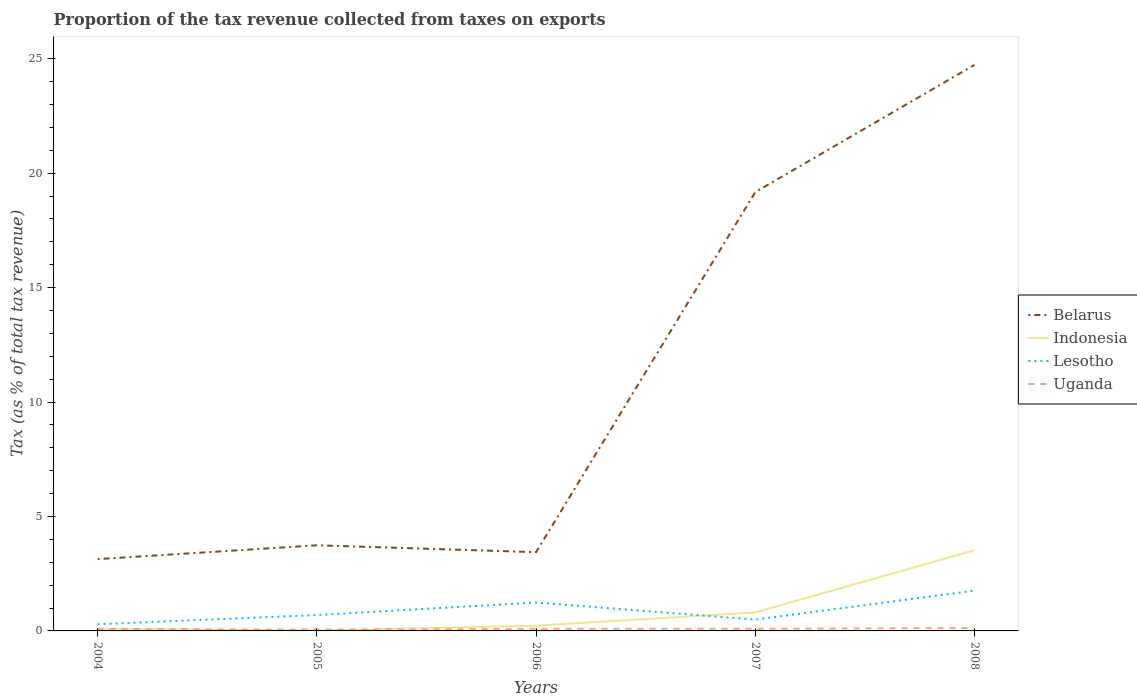Does the line corresponding to Belarus intersect with the line corresponding to Uganda?
Give a very brief answer. No. Across all years, what is the maximum proportion of the tax revenue collected in Indonesia?
Offer a terse response. 0.02. In which year was the proportion of the tax revenue collected in Indonesia maximum?
Give a very brief answer. 2005. What is the total proportion of the tax revenue collected in Indonesia in the graph?
Offer a terse response. -3.3. What is the difference between the highest and the second highest proportion of the tax revenue collected in Indonesia?
Your answer should be compact. 3.51. What is the difference between the highest and the lowest proportion of the tax revenue collected in Uganda?
Offer a very short reply. 2. Is the proportion of the tax revenue collected in Uganda strictly greater than the proportion of the tax revenue collected in Indonesia over the years?
Your answer should be very brief. No. How many lines are there?
Provide a succinct answer. 4. Are the values on the major ticks of Y-axis written in scientific E-notation?
Offer a very short reply. No. Does the graph contain grids?
Provide a short and direct response. No. Where does the legend appear in the graph?
Offer a very short reply. Center right. How many legend labels are there?
Make the answer very short. 4. How are the legend labels stacked?
Your answer should be very brief. Vertical. What is the title of the graph?
Give a very brief answer. Proportion of the tax revenue collected from taxes on exports. What is the label or title of the X-axis?
Keep it short and to the point. Years. What is the label or title of the Y-axis?
Make the answer very short. Tax (as % of total tax revenue). What is the Tax (as % of total tax revenue) of Belarus in 2004?
Ensure brevity in your answer.  3.14. What is the Tax (as % of total tax revenue) of Indonesia in 2004?
Offer a terse response. 0.11. What is the Tax (as % of total tax revenue) of Lesotho in 2004?
Keep it short and to the point. 0.29. What is the Tax (as % of total tax revenue) in Uganda in 2004?
Ensure brevity in your answer.  0.08. What is the Tax (as % of total tax revenue) of Belarus in 2005?
Ensure brevity in your answer.  3.74. What is the Tax (as % of total tax revenue) of Indonesia in 2005?
Your answer should be compact. 0.02. What is the Tax (as % of total tax revenue) in Lesotho in 2005?
Provide a succinct answer. 0.7. What is the Tax (as % of total tax revenue) in Uganda in 2005?
Offer a terse response. 0.06. What is the Tax (as % of total tax revenue) of Belarus in 2006?
Your response must be concise. 3.44. What is the Tax (as % of total tax revenue) of Indonesia in 2006?
Your answer should be very brief. 0.23. What is the Tax (as % of total tax revenue) in Lesotho in 2006?
Offer a terse response. 1.24. What is the Tax (as % of total tax revenue) in Uganda in 2006?
Your answer should be very brief. 0.09. What is the Tax (as % of total tax revenue) of Belarus in 2007?
Offer a very short reply. 19.17. What is the Tax (as % of total tax revenue) of Indonesia in 2007?
Offer a terse response. 0.81. What is the Tax (as % of total tax revenue) of Lesotho in 2007?
Your answer should be compact. 0.49. What is the Tax (as % of total tax revenue) of Uganda in 2007?
Provide a succinct answer. 0.09. What is the Tax (as % of total tax revenue) in Belarus in 2008?
Provide a short and direct response. 24.73. What is the Tax (as % of total tax revenue) in Indonesia in 2008?
Provide a short and direct response. 3.53. What is the Tax (as % of total tax revenue) in Lesotho in 2008?
Provide a succinct answer. 1.76. What is the Tax (as % of total tax revenue) of Uganda in 2008?
Provide a succinct answer. 0.13. Across all years, what is the maximum Tax (as % of total tax revenue) of Belarus?
Your answer should be very brief. 24.73. Across all years, what is the maximum Tax (as % of total tax revenue) in Indonesia?
Your response must be concise. 3.53. Across all years, what is the maximum Tax (as % of total tax revenue) in Lesotho?
Ensure brevity in your answer.  1.76. Across all years, what is the maximum Tax (as % of total tax revenue) of Uganda?
Make the answer very short. 0.13. Across all years, what is the minimum Tax (as % of total tax revenue) of Belarus?
Offer a terse response. 3.14. Across all years, what is the minimum Tax (as % of total tax revenue) in Indonesia?
Provide a short and direct response. 0.02. Across all years, what is the minimum Tax (as % of total tax revenue) in Lesotho?
Offer a terse response. 0.29. Across all years, what is the minimum Tax (as % of total tax revenue) of Uganda?
Your response must be concise. 0.06. What is the total Tax (as % of total tax revenue) of Belarus in the graph?
Offer a terse response. 54.23. What is the total Tax (as % of total tax revenue) of Indonesia in the graph?
Offer a terse response. 4.69. What is the total Tax (as % of total tax revenue) of Lesotho in the graph?
Your answer should be very brief. 4.48. What is the total Tax (as % of total tax revenue) of Uganda in the graph?
Provide a succinct answer. 0.46. What is the difference between the Tax (as % of total tax revenue) in Belarus in 2004 and that in 2005?
Provide a short and direct response. -0.6. What is the difference between the Tax (as % of total tax revenue) of Indonesia in 2004 and that in 2005?
Your answer should be compact. 0.09. What is the difference between the Tax (as % of total tax revenue) of Lesotho in 2004 and that in 2005?
Your answer should be very brief. -0.4. What is the difference between the Tax (as % of total tax revenue) in Uganda in 2004 and that in 2005?
Provide a succinct answer. 0.02. What is the difference between the Tax (as % of total tax revenue) in Belarus in 2004 and that in 2006?
Provide a short and direct response. -0.3. What is the difference between the Tax (as % of total tax revenue) of Indonesia in 2004 and that in 2006?
Keep it short and to the point. -0.12. What is the difference between the Tax (as % of total tax revenue) of Lesotho in 2004 and that in 2006?
Provide a short and direct response. -0.95. What is the difference between the Tax (as % of total tax revenue) of Uganda in 2004 and that in 2006?
Your answer should be compact. -0.01. What is the difference between the Tax (as % of total tax revenue) in Belarus in 2004 and that in 2007?
Your response must be concise. -16.04. What is the difference between the Tax (as % of total tax revenue) of Indonesia in 2004 and that in 2007?
Provide a short and direct response. -0.7. What is the difference between the Tax (as % of total tax revenue) in Lesotho in 2004 and that in 2007?
Keep it short and to the point. -0.2. What is the difference between the Tax (as % of total tax revenue) in Uganda in 2004 and that in 2007?
Ensure brevity in your answer.  -0.01. What is the difference between the Tax (as % of total tax revenue) of Belarus in 2004 and that in 2008?
Your answer should be very brief. -21.6. What is the difference between the Tax (as % of total tax revenue) in Indonesia in 2004 and that in 2008?
Offer a terse response. -3.42. What is the difference between the Tax (as % of total tax revenue) of Lesotho in 2004 and that in 2008?
Offer a very short reply. -1.47. What is the difference between the Tax (as % of total tax revenue) in Uganda in 2004 and that in 2008?
Provide a short and direct response. -0.04. What is the difference between the Tax (as % of total tax revenue) of Belarus in 2005 and that in 2006?
Your answer should be compact. 0.3. What is the difference between the Tax (as % of total tax revenue) in Indonesia in 2005 and that in 2006?
Your answer should be very brief. -0.21. What is the difference between the Tax (as % of total tax revenue) of Lesotho in 2005 and that in 2006?
Your response must be concise. -0.55. What is the difference between the Tax (as % of total tax revenue) of Uganda in 2005 and that in 2006?
Offer a terse response. -0.03. What is the difference between the Tax (as % of total tax revenue) in Belarus in 2005 and that in 2007?
Provide a short and direct response. -15.43. What is the difference between the Tax (as % of total tax revenue) of Indonesia in 2005 and that in 2007?
Give a very brief answer. -0.79. What is the difference between the Tax (as % of total tax revenue) in Lesotho in 2005 and that in 2007?
Make the answer very short. 0.2. What is the difference between the Tax (as % of total tax revenue) in Uganda in 2005 and that in 2007?
Your answer should be very brief. -0.03. What is the difference between the Tax (as % of total tax revenue) in Belarus in 2005 and that in 2008?
Give a very brief answer. -20.99. What is the difference between the Tax (as % of total tax revenue) of Indonesia in 2005 and that in 2008?
Your answer should be very brief. -3.51. What is the difference between the Tax (as % of total tax revenue) of Lesotho in 2005 and that in 2008?
Keep it short and to the point. -1.07. What is the difference between the Tax (as % of total tax revenue) of Uganda in 2005 and that in 2008?
Provide a succinct answer. -0.07. What is the difference between the Tax (as % of total tax revenue) of Belarus in 2006 and that in 2007?
Provide a short and direct response. -15.73. What is the difference between the Tax (as % of total tax revenue) of Indonesia in 2006 and that in 2007?
Your answer should be very brief. -0.58. What is the difference between the Tax (as % of total tax revenue) of Lesotho in 2006 and that in 2007?
Provide a succinct answer. 0.75. What is the difference between the Tax (as % of total tax revenue) in Uganda in 2006 and that in 2007?
Provide a succinct answer. -0. What is the difference between the Tax (as % of total tax revenue) in Belarus in 2006 and that in 2008?
Your answer should be very brief. -21.29. What is the difference between the Tax (as % of total tax revenue) in Indonesia in 2006 and that in 2008?
Make the answer very short. -3.3. What is the difference between the Tax (as % of total tax revenue) of Lesotho in 2006 and that in 2008?
Provide a succinct answer. -0.52. What is the difference between the Tax (as % of total tax revenue) of Uganda in 2006 and that in 2008?
Provide a short and direct response. -0.04. What is the difference between the Tax (as % of total tax revenue) of Belarus in 2007 and that in 2008?
Your response must be concise. -5.56. What is the difference between the Tax (as % of total tax revenue) in Indonesia in 2007 and that in 2008?
Make the answer very short. -2.72. What is the difference between the Tax (as % of total tax revenue) in Lesotho in 2007 and that in 2008?
Provide a short and direct response. -1.27. What is the difference between the Tax (as % of total tax revenue) of Uganda in 2007 and that in 2008?
Your answer should be very brief. -0.04. What is the difference between the Tax (as % of total tax revenue) in Belarus in 2004 and the Tax (as % of total tax revenue) in Indonesia in 2005?
Your response must be concise. 3.12. What is the difference between the Tax (as % of total tax revenue) of Belarus in 2004 and the Tax (as % of total tax revenue) of Lesotho in 2005?
Provide a short and direct response. 2.44. What is the difference between the Tax (as % of total tax revenue) in Belarus in 2004 and the Tax (as % of total tax revenue) in Uganda in 2005?
Your answer should be very brief. 3.08. What is the difference between the Tax (as % of total tax revenue) of Indonesia in 2004 and the Tax (as % of total tax revenue) of Lesotho in 2005?
Provide a short and direct response. -0.59. What is the difference between the Tax (as % of total tax revenue) of Indonesia in 2004 and the Tax (as % of total tax revenue) of Uganda in 2005?
Make the answer very short. 0.04. What is the difference between the Tax (as % of total tax revenue) of Lesotho in 2004 and the Tax (as % of total tax revenue) of Uganda in 2005?
Provide a succinct answer. 0.23. What is the difference between the Tax (as % of total tax revenue) of Belarus in 2004 and the Tax (as % of total tax revenue) of Indonesia in 2006?
Keep it short and to the point. 2.91. What is the difference between the Tax (as % of total tax revenue) of Belarus in 2004 and the Tax (as % of total tax revenue) of Lesotho in 2006?
Offer a terse response. 1.9. What is the difference between the Tax (as % of total tax revenue) in Belarus in 2004 and the Tax (as % of total tax revenue) in Uganda in 2006?
Give a very brief answer. 3.05. What is the difference between the Tax (as % of total tax revenue) in Indonesia in 2004 and the Tax (as % of total tax revenue) in Lesotho in 2006?
Your answer should be compact. -1.14. What is the difference between the Tax (as % of total tax revenue) in Indonesia in 2004 and the Tax (as % of total tax revenue) in Uganda in 2006?
Provide a short and direct response. 0.01. What is the difference between the Tax (as % of total tax revenue) in Lesotho in 2004 and the Tax (as % of total tax revenue) in Uganda in 2006?
Your answer should be compact. 0.2. What is the difference between the Tax (as % of total tax revenue) of Belarus in 2004 and the Tax (as % of total tax revenue) of Indonesia in 2007?
Offer a terse response. 2.33. What is the difference between the Tax (as % of total tax revenue) in Belarus in 2004 and the Tax (as % of total tax revenue) in Lesotho in 2007?
Keep it short and to the point. 2.64. What is the difference between the Tax (as % of total tax revenue) of Belarus in 2004 and the Tax (as % of total tax revenue) of Uganda in 2007?
Provide a short and direct response. 3.04. What is the difference between the Tax (as % of total tax revenue) in Indonesia in 2004 and the Tax (as % of total tax revenue) in Lesotho in 2007?
Provide a succinct answer. -0.39. What is the difference between the Tax (as % of total tax revenue) in Indonesia in 2004 and the Tax (as % of total tax revenue) in Uganda in 2007?
Keep it short and to the point. 0.01. What is the difference between the Tax (as % of total tax revenue) in Lesotho in 2004 and the Tax (as % of total tax revenue) in Uganda in 2007?
Keep it short and to the point. 0.2. What is the difference between the Tax (as % of total tax revenue) of Belarus in 2004 and the Tax (as % of total tax revenue) of Indonesia in 2008?
Make the answer very short. -0.39. What is the difference between the Tax (as % of total tax revenue) of Belarus in 2004 and the Tax (as % of total tax revenue) of Lesotho in 2008?
Provide a short and direct response. 1.38. What is the difference between the Tax (as % of total tax revenue) of Belarus in 2004 and the Tax (as % of total tax revenue) of Uganda in 2008?
Your answer should be compact. 3.01. What is the difference between the Tax (as % of total tax revenue) of Indonesia in 2004 and the Tax (as % of total tax revenue) of Lesotho in 2008?
Offer a very short reply. -1.66. What is the difference between the Tax (as % of total tax revenue) of Indonesia in 2004 and the Tax (as % of total tax revenue) of Uganda in 2008?
Your answer should be very brief. -0.02. What is the difference between the Tax (as % of total tax revenue) in Lesotho in 2004 and the Tax (as % of total tax revenue) in Uganda in 2008?
Offer a very short reply. 0.16. What is the difference between the Tax (as % of total tax revenue) of Belarus in 2005 and the Tax (as % of total tax revenue) of Indonesia in 2006?
Keep it short and to the point. 3.51. What is the difference between the Tax (as % of total tax revenue) of Belarus in 2005 and the Tax (as % of total tax revenue) of Lesotho in 2006?
Give a very brief answer. 2.5. What is the difference between the Tax (as % of total tax revenue) in Belarus in 2005 and the Tax (as % of total tax revenue) in Uganda in 2006?
Keep it short and to the point. 3.65. What is the difference between the Tax (as % of total tax revenue) in Indonesia in 2005 and the Tax (as % of total tax revenue) in Lesotho in 2006?
Your response must be concise. -1.22. What is the difference between the Tax (as % of total tax revenue) in Indonesia in 2005 and the Tax (as % of total tax revenue) in Uganda in 2006?
Make the answer very short. -0.07. What is the difference between the Tax (as % of total tax revenue) of Lesotho in 2005 and the Tax (as % of total tax revenue) of Uganda in 2006?
Your response must be concise. 0.6. What is the difference between the Tax (as % of total tax revenue) of Belarus in 2005 and the Tax (as % of total tax revenue) of Indonesia in 2007?
Your answer should be compact. 2.93. What is the difference between the Tax (as % of total tax revenue) of Belarus in 2005 and the Tax (as % of total tax revenue) of Lesotho in 2007?
Offer a very short reply. 3.25. What is the difference between the Tax (as % of total tax revenue) in Belarus in 2005 and the Tax (as % of total tax revenue) in Uganda in 2007?
Your answer should be very brief. 3.65. What is the difference between the Tax (as % of total tax revenue) in Indonesia in 2005 and the Tax (as % of total tax revenue) in Lesotho in 2007?
Offer a very short reply. -0.48. What is the difference between the Tax (as % of total tax revenue) in Indonesia in 2005 and the Tax (as % of total tax revenue) in Uganda in 2007?
Keep it short and to the point. -0.08. What is the difference between the Tax (as % of total tax revenue) of Lesotho in 2005 and the Tax (as % of total tax revenue) of Uganda in 2007?
Your answer should be very brief. 0.6. What is the difference between the Tax (as % of total tax revenue) in Belarus in 2005 and the Tax (as % of total tax revenue) in Indonesia in 2008?
Your answer should be compact. 0.21. What is the difference between the Tax (as % of total tax revenue) of Belarus in 2005 and the Tax (as % of total tax revenue) of Lesotho in 2008?
Your answer should be very brief. 1.98. What is the difference between the Tax (as % of total tax revenue) of Belarus in 2005 and the Tax (as % of total tax revenue) of Uganda in 2008?
Your response must be concise. 3.61. What is the difference between the Tax (as % of total tax revenue) in Indonesia in 2005 and the Tax (as % of total tax revenue) in Lesotho in 2008?
Keep it short and to the point. -1.74. What is the difference between the Tax (as % of total tax revenue) of Indonesia in 2005 and the Tax (as % of total tax revenue) of Uganda in 2008?
Your answer should be very brief. -0.11. What is the difference between the Tax (as % of total tax revenue) of Lesotho in 2005 and the Tax (as % of total tax revenue) of Uganda in 2008?
Your answer should be compact. 0.57. What is the difference between the Tax (as % of total tax revenue) of Belarus in 2006 and the Tax (as % of total tax revenue) of Indonesia in 2007?
Offer a terse response. 2.63. What is the difference between the Tax (as % of total tax revenue) of Belarus in 2006 and the Tax (as % of total tax revenue) of Lesotho in 2007?
Offer a very short reply. 2.95. What is the difference between the Tax (as % of total tax revenue) in Belarus in 2006 and the Tax (as % of total tax revenue) in Uganda in 2007?
Your answer should be very brief. 3.35. What is the difference between the Tax (as % of total tax revenue) of Indonesia in 2006 and the Tax (as % of total tax revenue) of Lesotho in 2007?
Your answer should be compact. -0.27. What is the difference between the Tax (as % of total tax revenue) of Indonesia in 2006 and the Tax (as % of total tax revenue) of Uganda in 2007?
Your response must be concise. 0.14. What is the difference between the Tax (as % of total tax revenue) in Lesotho in 2006 and the Tax (as % of total tax revenue) in Uganda in 2007?
Give a very brief answer. 1.15. What is the difference between the Tax (as % of total tax revenue) in Belarus in 2006 and the Tax (as % of total tax revenue) in Indonesia in 2008?
Make the answer very short. -0.09. What is the difference between the Tax (as % of total tax revenue) of Belarus in 2006 and the Tax (as % of total tax revenue) of Lesotho in 2008?
Provide a short and direct response. 1.68. What is the difference between the Tax (as % of total tax revenue) in Belarus in 2006 and the Tax (as % of total tax revenue) in Uganda in 2008?
Provide a short and direct response. 3.31. What is the difference between the Tax (as % of total tax revenue) of Indonesia in 2006 and the Tax (as % of total tax revenue) of Lesotho in 2008?
Give a very brief answer. -1.53. What is the difference between the Tax (as % of total tax revenue) in Indonesia in 2006 and the Tax (as % of total tax revenue) in Uganda in 2008?
Keep it short and to the point. 0.1. What is the difference between the Tax (as % of total tax revenue) in Lesotho in 2006 and the Tax (as % of total tax revenue) in Uganda in 2008?
Your response must be concise. 1.11. What is the difference between the Tax (as % of total tax revenue) in Belarus in 2007 and the Tax (as % of total tax revenue) in Indonesia in 2008?
Your response must be concise. 15.65. What is the difference between the Tax (as % of total tax revenue) of Belarus in 2007 and the Tax (as % of total tax revenue) of Lesotho in 2008?
Make the answer very short. 17.41. What is the difference between the Tax (as % of total tax revenue) of Belarus in 2007 and the Tax (as % of total tax revenue) of Uganda in 2008?
Provide a succinct answer. 19.05. What is the difference between the Tax (as % of total tax revenue) in Indonesia in 2007 and the Tax (as % of total tax revenue) in Lesotho in 2008?
Your response must be concise. -0.95. What is the difference between the Tax (as % of total tax revenue) in Indonesia in 2007 and the Tax (as % of total tax revenue) in Uganda in 2008?
Make the answer very short. 0.68. What is the difference between the Tax (as % of total tax revenue) of Lesotho in 2007 and the Tax (as % of total tax revenue) of Uganda in 2008?
Make the answer very short. 0.37. What is the average Tax (as % of total tax revenue) in Belarus per year?
Offer a terse response. 10.85. What is the average Tax (as % of total tax revenue) in Indonesia per year?
Keep it short and to the point. 0.94. What is the average Tax (as % of total tax revenue) of Lesotho per year?
Provide a short and direct response. 0.9. What is the average Tax (as % of total tax revenue) in Uganda per year?
Provide a short and direct response. 0.09. In the year 2004, what is the difference between the Tax (as % of total tax revenue) of Belarus and Tax (as % of total tax revenue) of Indonesia?
Your response must be concise. 3.03. In the year 2004, what is the difference between the Tax (as % of total tax revenue) of Belarus and Tax (as % of total tax revenue) of Lesotho?
Your answer should be compact. 2.85. In the year 2004, what is the difference between the Tax (as % of total tax revenue) in Belarus and Tax (as % of total tax revenue) in Uganda?
Your answer should be very brief. 3.05. In the year 2004, what is the difference between the Tax (as % of total tax revenue) of Indonesia and Tax (as % of total tax revenue) of Lesotho?
Ensure brevity in your answer.  -0.19. In the year 2004, what is the difference between the Tax (as % of total tax revenue) in Indonesia and Tax (as % of total tax revenue) in Uganda?
Your answer should be compact. 0.02. In the year 2004, what is the difference between the Tax (as % of total tax revenue) in Lesotho and Tax (as % of total tax revenue) in Uganda?
Make the answer very short. 0.21. In the year 2005, what is the difference between the Tax (as % of total tax revenue) in Belarus and Tax (as % of total tax revenue) in Indonesia?
Provide a short and direct response. 3.72. In the year 2005, what is the difference between the Tax (as % of total tax revenue) of Belarus and Tax (as % of total tax revenue) of Lesotho?
Keep it short and to the point. 3.05. In the year 2005, what is the difference between the Tax (as % of total tax revenue) of Belarus and Tax (as % of total tax revenue) of Uganda?
Your answer should be compact. 3.68. In the year 2005, what is the difference between the Tax (as % of total tax revenue) of Indonesia and Tax (as % of total tax revenue) of Lesotho?
Provide a short and direct response. -0.68. In the year 2005, what is the difference between the Tax (as % of total tax revenue) in Indonesia and Tax (as % of total tax revenue) in Uganda?
Provide a succinct answer. -0.04. In the year 2005, what is the difference between the Tax (as % of total tax revenue) in Lesotho and Tax (as % of total tax revenue) in Uganda?
Keep it short and to the point. 0.63. In the year 2006, what is the difference between the Tax (as % of total tax revenue) in Belarus and Tax (as % of total tax revenue) in Indonesia?
Keep it short and to the point. 3.21. In the year 2006, what is the difference between the Tax (as % of total tax revenue) in Belarus and Tax (as % of total tax revenue) in Lesotho?
Provide a succinct answer. 2.2. In the year 2006, what is the difference between the Tax (as % of total tax revenue) of Belarus and Tax (as % of total tax revenue) of Uganda?
Make the answer very short. 3.35. In the year 2006, what is the difference between the Tax (as % of total tax revenue) of Indonesia and Tax (as % of total tax revenue) of Lesotho?
Provide a succinct answer. -1.01. In the year 2006, what is the difference between the Tax (as % of total tax revenue) in Indonesia and Tax (as % of total tax revenue) in Uganda?
Provide a short and direct response. 0.14. In the year 2006, what is the difference between the Tax (as % of total tax revenue) of Lesotho and Tax (as % of total tax revenue) of Uganda?
Your response must be concise. 1.15. In the year 2007, what is the difference between the Tax (as % of total tax revenue) in Belarus and Tax (as % of total tax revenue) in Indonesia?
Provide a short and direct response. 18.37. In the year 2007, what is the difference between the Tax (as % of total tax revenue) in Belarus and Tax (as % of total tax revenue) in Lesotho?
Provide a succinct answer. 18.68. In the year 2007, what is the difference between the Tax (as % of total tax revenue) of Belarus and Tax (as % of total tax revenue) of Uganda?
Offer a very short reply. 19.08. In the year 2007, what is the difference between the Tax (as % of total tax revenue) of Indonesia and Tax (as % of total tax revenue) of Lesotho?
Make the answer very short. 0.31. In the year 2007, what is the difference between the Tax (as % of total tax revenue) in Indonesia and Tax (as % of total tax revenue) in Uganda?
Your response must be concise. 0.71. In the year 2007, what is the difference between the Tax (as % of total tax revenue) in Lesotho and Tax (as % of total tax revenue) in Uganda?
Offer a very short reply. 0.4. In the year 2008, what is the difference between the Tax (as % of total tax revenue) of Belarus and Tax (as % of total tax revenue) of Indonesia?
Provide a short and direct response. 21.21. In the year 2008, what is the difference between the Tax (as % of total tax revenue) in Belarus and Tax (as % of total tax revenue) in Lesotho?
Offer a terse response. 22.97. In the year 2008, what is the difference between the Tax (as % of total tax revenue) of Belarus and Tax (as % of total tax revenue) of Uganda?
Keep it short and to the point. 24.61. In the year 2008, what is the difference between the Tax (as % of total tax revenue) of Indonesia and Tax (as % of total tax revenue) of Lesotho?
Your answer should be very brief. 1.77. In the year 2008, what is the difference between the Tax (as % of total tax revenue) of Indonesia and Tax (as % of total tax revenue) of Uganda?
Give a very brief answer. 3.4. In the year 2008, what is the difference between the Tax (as % of total tax revenue) of Lesotho and Tax (as % of total tax revenue) of Uganda?
Keep it short and to the point. 1.63. What is the ratio of the Tax (as % of total tax revenue) of Belarus in 2004 to that in 2005?
Make the answer very short. 0.84. What is the ratio of the Tax (as % of total tax revenue) in Indonesia in 2004 to that in 2005?
Your response must be concise. 6.08. What is the ratio of the Tax (as % of total tax revenue) in Lesotho in 2004 to that in 2005?
Offer a terse response. 0.42. What is the ratio of the Tax (as % of total tax revenue) of Uganda in 2004 to that in 2005?
Make the answer very short. 1.4. What is the ratio of the Tax (as % of total tax revenue) in Belarus in 2004 to that in 2006?
Provide a succinct answer. 0.91. What is the ratio of the Tax (as % of total tax revenue) in Indonesia in 2004 to that in 2006?
Your answer should be very brief. 0.46. What is the ratio of the Tax (as % of total tax revenue) in Lesotho in 2004 to that in 2006?
Provide a succinct answer. 0.23. What is the ratio of the Tax (as % of total tax revenue) of Uganda in 2004 to that in 2006?
Keep it short and to the point. 0.93. What is the ratio of the Tax (as % of total tax revenue) in Belarus in 2004 to that in 2007?
Offer a terse response. 0.16. What is the ratio of the Tax (as % of total tax revenue) in Indonesia in 2004 to that in 2007?
Offer a terse response. 0.13. What is the ratio of the Tax (as % of total tax revenue) of Lesotho in 2004 to that in 2007?
Provide a succinct answer. 0.59. What is the ratio of the Tax (as % of total tax revenue) of Uganda in 2004 to that in 2007?
Give a very brief answer. 0.91. What is the ratio of the Tax (as % of total tax revenue) in Belarus in 2004 to that in 2008?
Offer a very short reply. 0.13. What is the ratio of the Tax (as % of total tax revenue) in Indonesia in 2004 to that in 2008?
Offer a terse response. 0.03. What is the ratio of the Tax (as % of total tax revenue) in Lesotho in 2004 to that in 2008?
Ensure brevity in your answer.  0.17. What is the ratio of the Tax (as % of total tax revenue) of Uganda in 2004 to that in 2008?
Give a very brief answer. 0.66. What is the ratio of the Tax (as % of total tax revenue) of Belarus in 2005 to that in 2006?
Your response must be concise. 1.09. What is the ratio of the Tax (as % of total tax revenue) of Indonesia in 2005 to that in 2006?
Make the answer very short. 0.08. What is the ratio of the Tax (as % of total tax revenue) in Lesotho in 2005 to that in 2006?
Provide a succinct answer. 0.56. What is the ratio of the Tax (as % of total tax revenue) in Uganda in 2005 to that in 2006?
Offer a terse response. 0.66. What is the ratio of the Tax (as % of total tax revenue) of Belarus in 2005 to that in 2007?
Make the answer very short. 0.2. What is the ratio of the Tax (as % of total tax revenue) in Indonesia in 2005 to that in 2007?
Offer a very short reply. 0.02. What is the ratio of the Tax (as % of total tax revenue) of Lesotho in 2005 to that in 2007?
Provide a succinct answer. 1.4. What is the ratio of the Tax (as % of total tax revenue) of Uganda in 2005 to that in 2007?
Your answer should be compact. 0.65. What is the ratio of the Tax (as % of total tax revenue) in Belarus in 2005 to that in 2008?
Your answer should be compact. 0.15. What is the ratio of the Tax (as % of total tax revenue) in Indonesia in 2005 to that in 2008?
Give a very brief answer. 0. What is the ratio of the Tax (as % of total tax revenue) of Lesotho in 2005 to that in 2008?
Your response must be concise. 0.39. What is the ratio of the Tax (as % of total tax revenue) in Uganda in 2005 to that in 2008?
Your answer should be compact. 0.47. What is the ratio of the Tax (as % of total tax revenue) in Belarus in 2006 to that in 2007?
Make the answer very short. 0.18. What is the ratio of the Tax (as % of total tax revenue) in Indonesia in 2006 to that in 2007?
Offer a very short reply. 0.28. What is the ratio of the Tax (as % of total tax revenue) of Lesotho in 2006 to that in 2007?
Provide a succinct answer. 2.51. What is the ratio of the Tax (as % of total tax revenue) of Uganda in 2006 to that in 2007?
Make the answer very short. 0.99. What is the ratio of the Tax (as % of total tax revenue) of Belarus in 2006 to that in 2008?
Provide a short and direct response. 0.14. What is the ratio of the Tax (as % of total tax revenue) in Indonesia in 2006 to that in 2008?
Offer a very short reply. 0.07. What is the ratio of the Tax (as % of total tax revenue) of Lesotho in 2006 to that in 2008?
Provide a short and direct response. 0.7. What is the ratio of the Tax (as % of total tax revenue) in Uganda in 2006 to that in 2008?
Provide a succinct answer. 0.71. What is the ratio of the Tax (as % of total tax revenue) in Belarus in 2007 to that in 2008?
Provide a short and direct response. 0.78. What is the ratio of the Tax (as % of total tax revenue) in Indonesia in 2007 to that in 2008?
Provide a short and direct response. 0.23. What is the ratio of the Tax (as % of total tax revenue) of Lesotho in 2007 to that in 2008?
Ensure brevity in your answer.  0.28. What is the ratio of the Tax (as % of total tax revenue) in Uganda in 2007 to that in 2008?
Keep it short and to the point. 0.72. What is the difference between the highest and the second highest Tax (as % of total tax revenue) of Belarus?
Provide a succinct answer. 5.56. What is the difference between the highest and the second highest Tax (as % of total tax revenue) of Indonesia?
Offer a terse response. 2.72. What is the difference between the highest and the second highest Tax (as % of total tax revenue) in Lesotho?
Provide a short and direct response. 0.52. What is the difference between the highest and the second highest Tax (as % of total tax revenue) of Uganda?
Ensure brevity in your answer.  0.04. What is the difference between the highest and the lowest Tax (as % of total tax revenue) of Belarus?
Make the answer very short. 21.6. What is the difference between the highest and the lowest Tax (as % of total tax revenue) in Indonesia?
Offer a very short reply. 3.51. What is the difference between the highest and the lowest Tax (as % of total tax revenue) in Lesotho?
Offer a terse response. 1.47. What is the difference between the highest and the lowest Tax (as % of total tax revenue) in Uganda?
Provide a succinct answer. 0.07. 